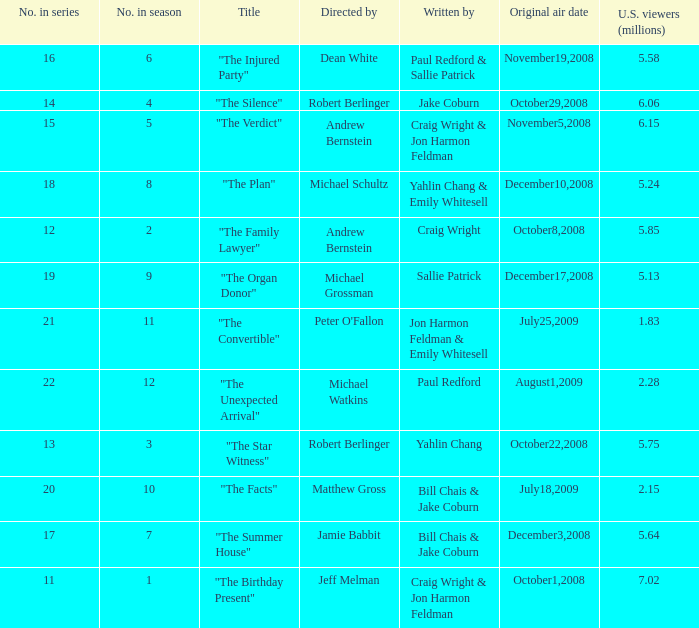What is the original air date of the episode directed by Jeff Melman? October1,2008. 